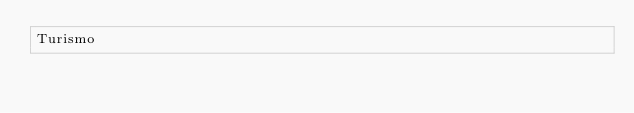Convert code to text. <code><loc_0><loc_0><loc_500><loc_500><_Rust_>Turismo
</code> 